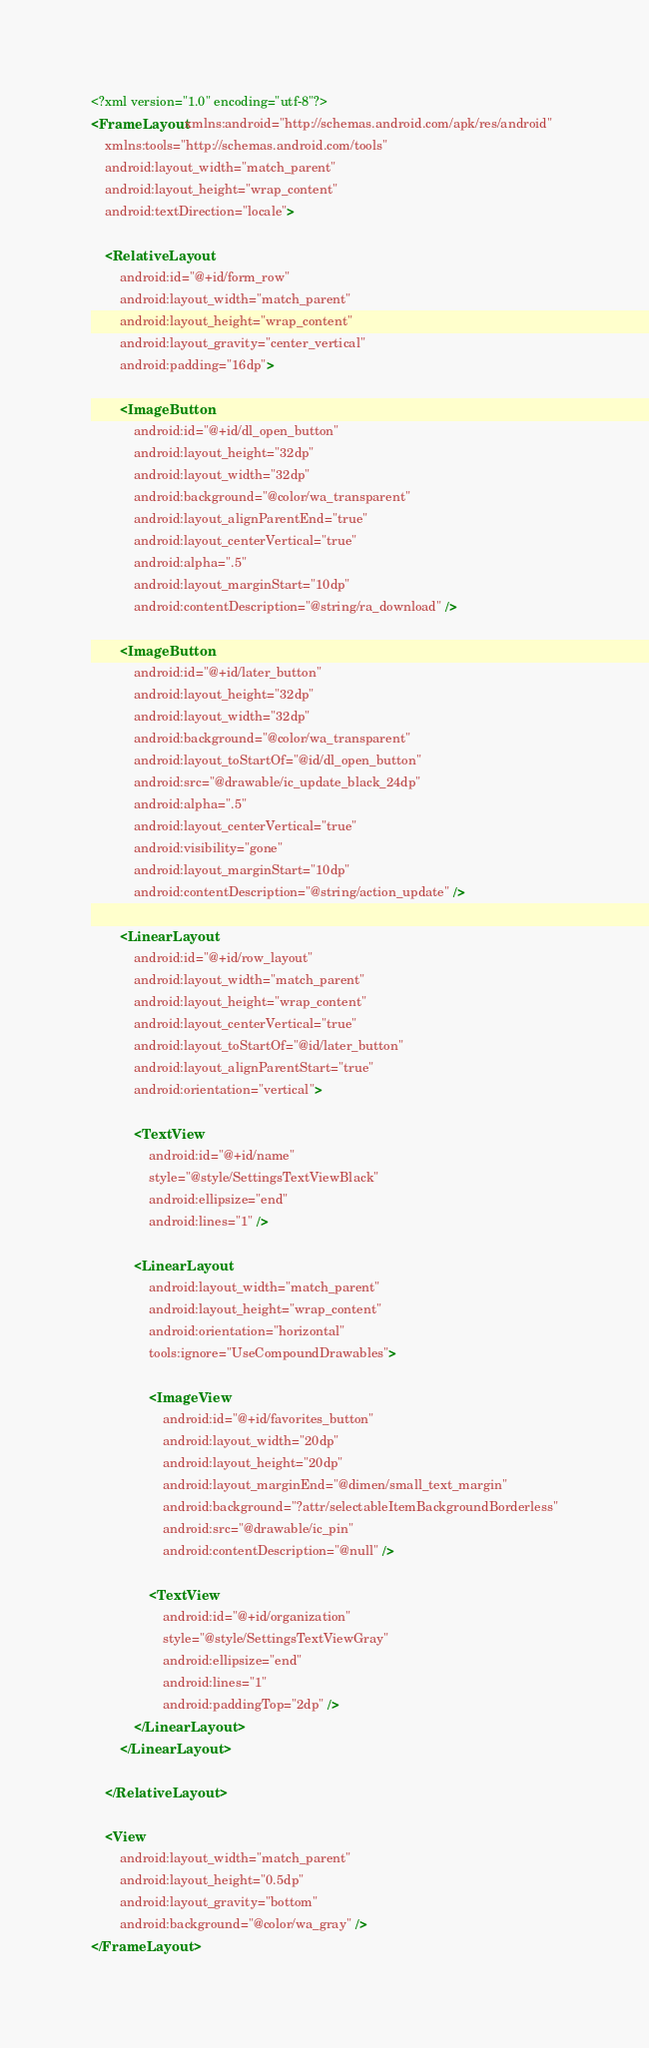<code> <loc_0><loc_0><loc_500><loc_500><_XML_><?xml version="1.0" encoding="utf-8"?>
<FrameLayout xmlns:android="http://schemas.android.com/apk/res/android"
    xmlns:tools="http://schemas.android.com/tools"
    android:layout_width="match_parent"
    android:layout_height="wrap_content"
    android:textDirection="locale">

    <RelativeLayout
        android:id="@+id/form_row"
        android:layout_width="match_parent"
        android:layout_height="wrap_content"
        android:layout_gravity="center_vertical"
        android:padding="16dp">

        <ImageButton
            android:id="@+id/dl_open_button"
            android:layout_height="32dp"
            android:layout_width="32dp"
            android:background="@color/wa_transparent"
            android:layout_alignParentEnd="true"
            android:layout_centerVertical="true"
            android:alpha=".5"
            android:layout_marginStart="10dp"
            android:contentDescription="@string/ra_download" />

        <ImageButton
            android:id="@+id/later_button"
            android:layout_height="32dp"
            android:layout_width="32dp"
            android:background="@color/wa_transparent"
            android:layout_toStartOf="@id/dl_open_button"
            android:src="@drawable/ic_update_black_24dp"
            android:alpha=".5"
            android:layout_centerVertical="true"
            android:visibility="gone"
            android:layout_marginStart="10dp"
            android:contentDescription="@string/action_update" />

        <LinearLayout
            android:id="@+id/row_layout"
            android:layout_width="match_parent"
            android:layout_height="wrap_content"
            android:layout_centerVertical="true"
            android:layout_toStartOf="@id/later_button"
            android:layout_alignParentStart="true"
            android:orientation="vertical">

            <TextView
                android:id="@+id/name"
                style="@style/SettingsTextViewBlack"
                android:ellipsize="end"
                android:lines="1" />

            <LinearLayout
                android:layout_width="match_parent"
                android:layout_height="wrap_content"
                android:orientation="horizontal"
                tools:ignore="UseCompoundDrawables">

                <ImageView
                    android:id="@+id/favorites_button"
                    android:layout_width="20dp"
                    android:layout_height="20dp"
                    android:layout_marginEnd="@dimen/small_text_margin"
                    android:background="?attr/selectableItemBackgroundBorderless"
                    android:src="@drawable/ic_pin"
                    android:contentDescription="@null" />

                <TextView
                    android:id="@+id/organization"
                    style="@style/SettingsTextViewGray"
                    android:ellipsize="end"
                    android:lines="1"
                    android:paddingTop="2dp" />
            </LinearLayout>
        </LinearLayout>

    </RelativeLayout>

    <View
        android:layout_width="match_parent"
        android:layout_height="0.5dp"
        android:layout_gravity="bottom"
        android:background="@color/wa_gray" />
</FrameLayout>
</code> 